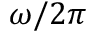<formula> <loc_0><loc_0><loc_500><loc_500>\omega / 2 \pi</formula> 